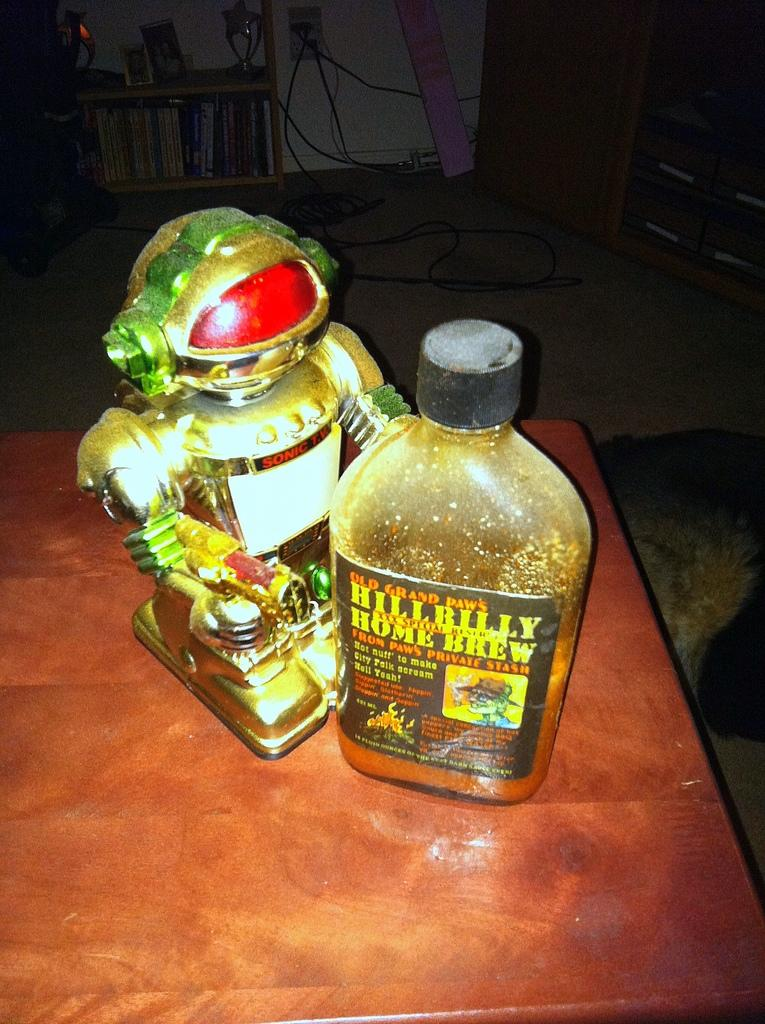<image>
Describe the image concisely. A bottle of Hillbilly Home Brew sits on a table next to a toy robot. 